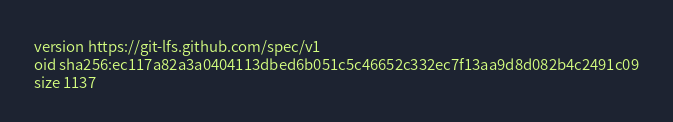Convert code to text. <code><loc_0><loc_0><loc_500><loc_500><_YAML_>version https://git-lfs.github.com/spec/v1
oid sha256:ec117a82a3a0404113dbed6b051c5c46652c332ec7f13aa9d8d082b4c2491c09
size 1137
</code> 